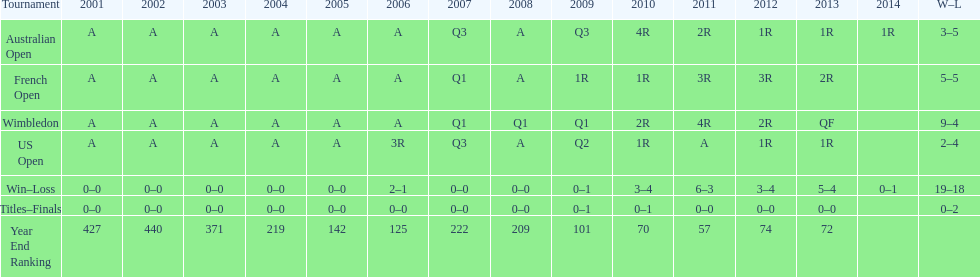What event has a "w-l" record of 5-5? French Open. 